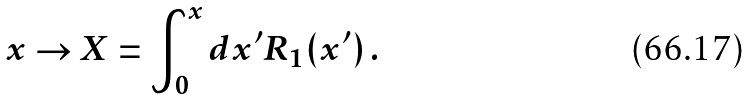Convert formula to latex. <formula><loc_0><loc_0><loc_500><loc_500>x \to X = \int _ { 0 } ^ { x } d x ^ { \prime } R _ { 1 } ( x ^ { \prime } ) \, .</formula> 